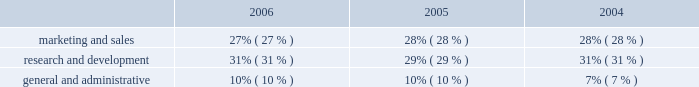Operating expenses as a percentage of total revenue .
Operating expense summary 2006 compared to 2005 overall operating expenses increased $ 122.5 million in 2006 , as compared to 2005 , primarily due to : 2022 an increase of $ 58.4 million in stock-based compensation expense due to our adoption of sfas no .
123r ; and 2022 an increase of $ 49.2 million in salary , benefits and other employee-related costs , primarily due to an increased number of employees and increases in bonus and commission costs , in part due to our acquisition of verisity ltd. , or verisity , in the second quarter of 2005 .
2005 compared to 2004 operating expenses increased $ 97.4 million in 2005 , as compared to 2004 , primarily due to : 2022 an increase of $ 63.3 million in employee salary and benefit costs , primarily due to our acquisition of verisity and increased bonus and commission costs ; 2022 an increase of $ 9.9 million in stock-based compensation expense due to grants of restricted stock and the assumption of options in our acquisitions ; 2022 an increase of $ 8.6 million in losses associated with the sale of installment contract receivables ; and 2022 an increase of $ 7.1 million in costs related to the retirement of our executive chairman and former president and chief executive officer in 2005 ; partially offset by 2022 our restructuring activities , as discussed below .
Marketing and sales 2006 compared to 2005 marketing and sales expenses increased $ 39.4 million in 2006 , as compared to 2005 , primarily due to : 2022 an increase of $ 14.8 million in stock-based compensation expense due to our adoption of sfas no .
123r ; 2022 an increase of $ 18.2 million in employee salary , commissions , benefits and other employee-related costs due to increased hiring of sales and technical personnel , and higher commissions earned resulting from an increase in 2006 sales performance ; and 2022 an increase of $ 7.8 million in marketing programs and customer-focused conferences due to our new marketing initiatives and increased travel to visit our customers .
2005 compared to 2004 marketing and sales expenses increased $ 33.1 million in 2005 , as compared to 2004 , primarily due to : 2022 an increase of $ 29.4 million in employee salary , commission and benefit costs due to increased hiring of sales and technical personnel and higher employee bonuses and commissions ; and 2022 an increase of $ 1.6 million in stock-based compensation expense due to grants of restricted stock and the assumption of options in our acquisitions ; partially offset by 2022 a decrease of $ 1.9 million in marketing program costs. .
What was the change in research and development expenses as a percentage of total revenue from 2005 to 2006? 
Computations: (31% - 29%)
Answer: 0.02. Operating expenses as a percentage of total revenue .
Operating expense summary 2006 compared to 2005 overall operating expenses increased $ 122.5 million in 2006 , as compared to 2005 , primarily due to : 2022 an increase of $ 58.4 million in stock-based compensation expense due to our adoption of sfas no .
123r ; and 2022 an increase of $ 49.2 million in salary , benefits and other employee-related costs , primarily due to an increased number of employees and increases in bonus and commission costs , in part due to our acquisition of verisity ltd. , or verisity , in the second quarter of 2005 .
2005 compared to 2004 operating expenses increased $ 97.4 million in 2005 , as compared to 2004 , primarily due to : 2022 an increase of $ 63.3 million in employee salary and benefit costs , primarily due to our acquisition of verisity and increased bonus and commission costs ; 2022 an increase of $ 9.9 million in stock-based compensation expense due to grants of restricted stock and the assumption of options in our acquisitions ; 2022 an increase of $ 8.6 million in losses associated with the sale of installment contract receivables ; and 2022 an increase of $ 7.1 million in costs related to the retirement of our executive chairman and former president and chief executive officer in 2005 ; partially offset by 2022 our restructuring activities , as discussed below .
Marketing and sales 2006 compared to 2005 marketing and sales expenses increased $ 39.4 million in 2006 , as compared to 2005 , primarily due to : 2022 an increase of $ 14.8 million in stock-based compensation expense due to our adoption of sfas no .
123r ; 2022 an increase of $ 18.2 million in employee salary , commissions , benefits and other employee-related costs due to increased hiring of sales and technical personnel , and higher commissions earned resulting from an increase in 2006 sales performance ; and 2022 an increase of $ 7.8 million in marketing programs and customer-focused conferences due to our new marketing initiatives and increased travel to visit our customers .
2005 compared to 2004 marketing and sales expenses increased $ 33.1 million in 2005 , as compared to 2004 , primarily due to : 2022 an increase of $ 29.4 million in employee salary , commission and benefit costs due to increased hiring of sales and technical personnel and higher employee bonuses and commissions ; and 2022 an increase of $ 1.6 million in stock-based compensation expense due to grants of restricted stock and the assumption of options in our acquisitions ; partially offset by 2022 a decrease of $ 1.9 million in marketing program costs. .
What portion of the increase of marketing and sales expense in 2006 is incurred by the increase in stock-based compensation expense due to our adoption of sfas no? 
Computations: (14.8 / 39.4)
Answer: 0.37563. 